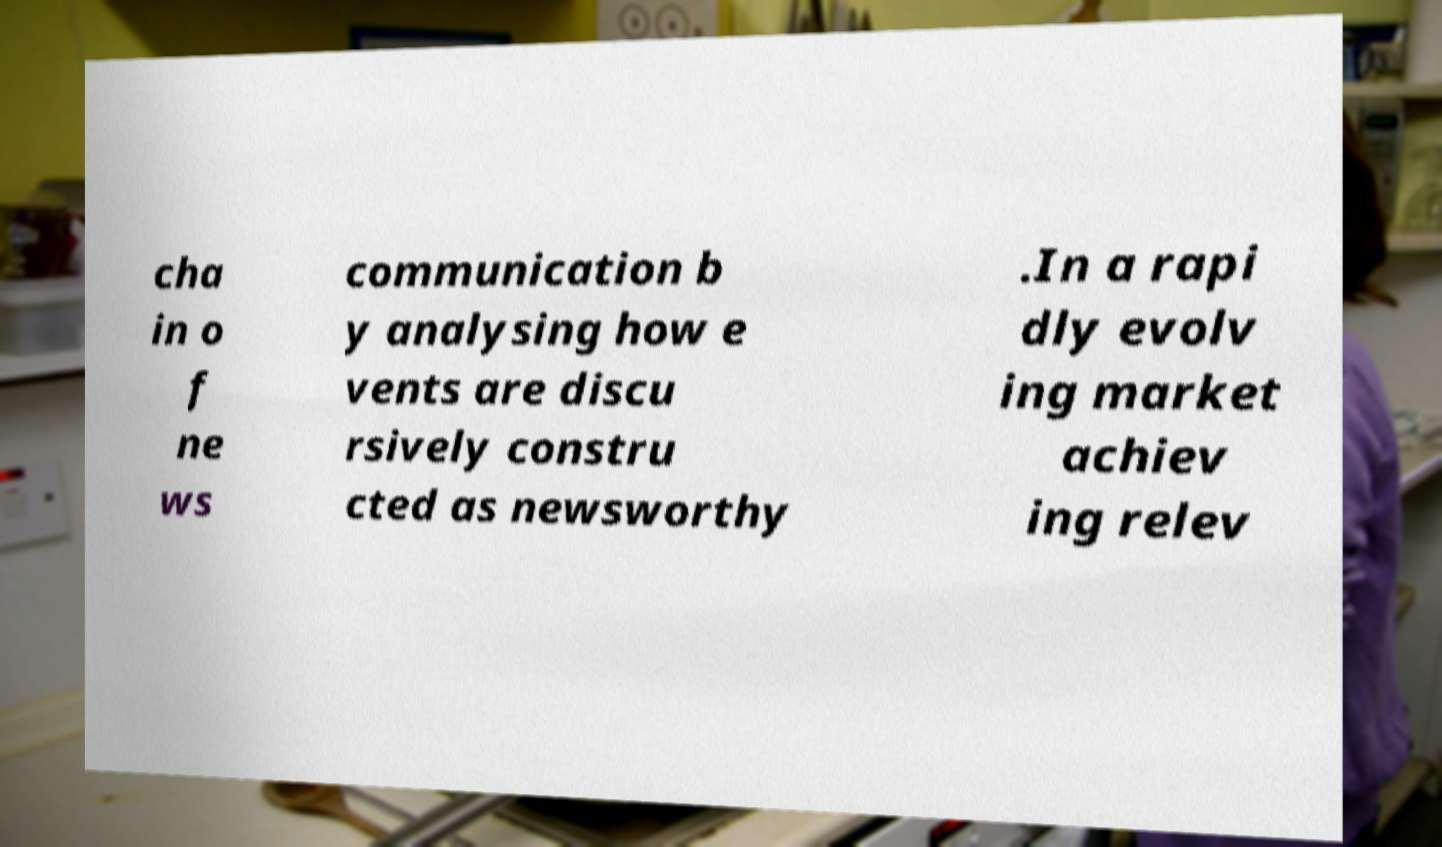Can you accurately transcribe the text from the provided image for me? cha in o f ne ws communication b y analysing how e vents are discu rsively constru cted as newsworthy .In a rapi dly evolv ing market achiev ing relev 